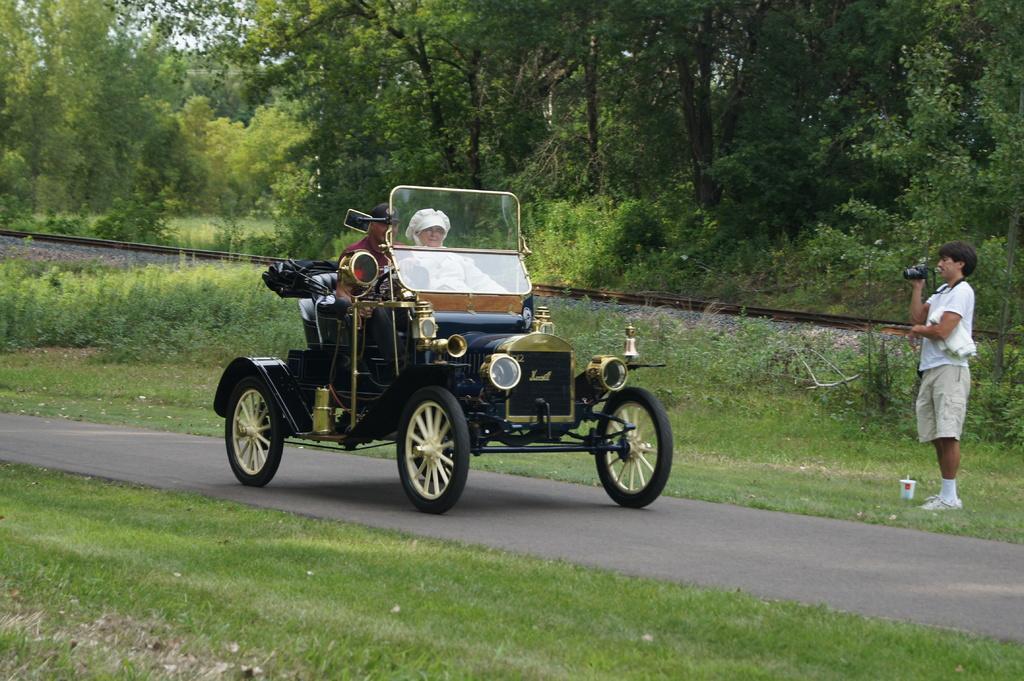Please provide a concise description of this image. In this picture I can see there is a car moving on the road, there is grass, and there is a person standing on the right side and clicking pictures, he is holding a camera. In the backdrop, I can see there are trees. 